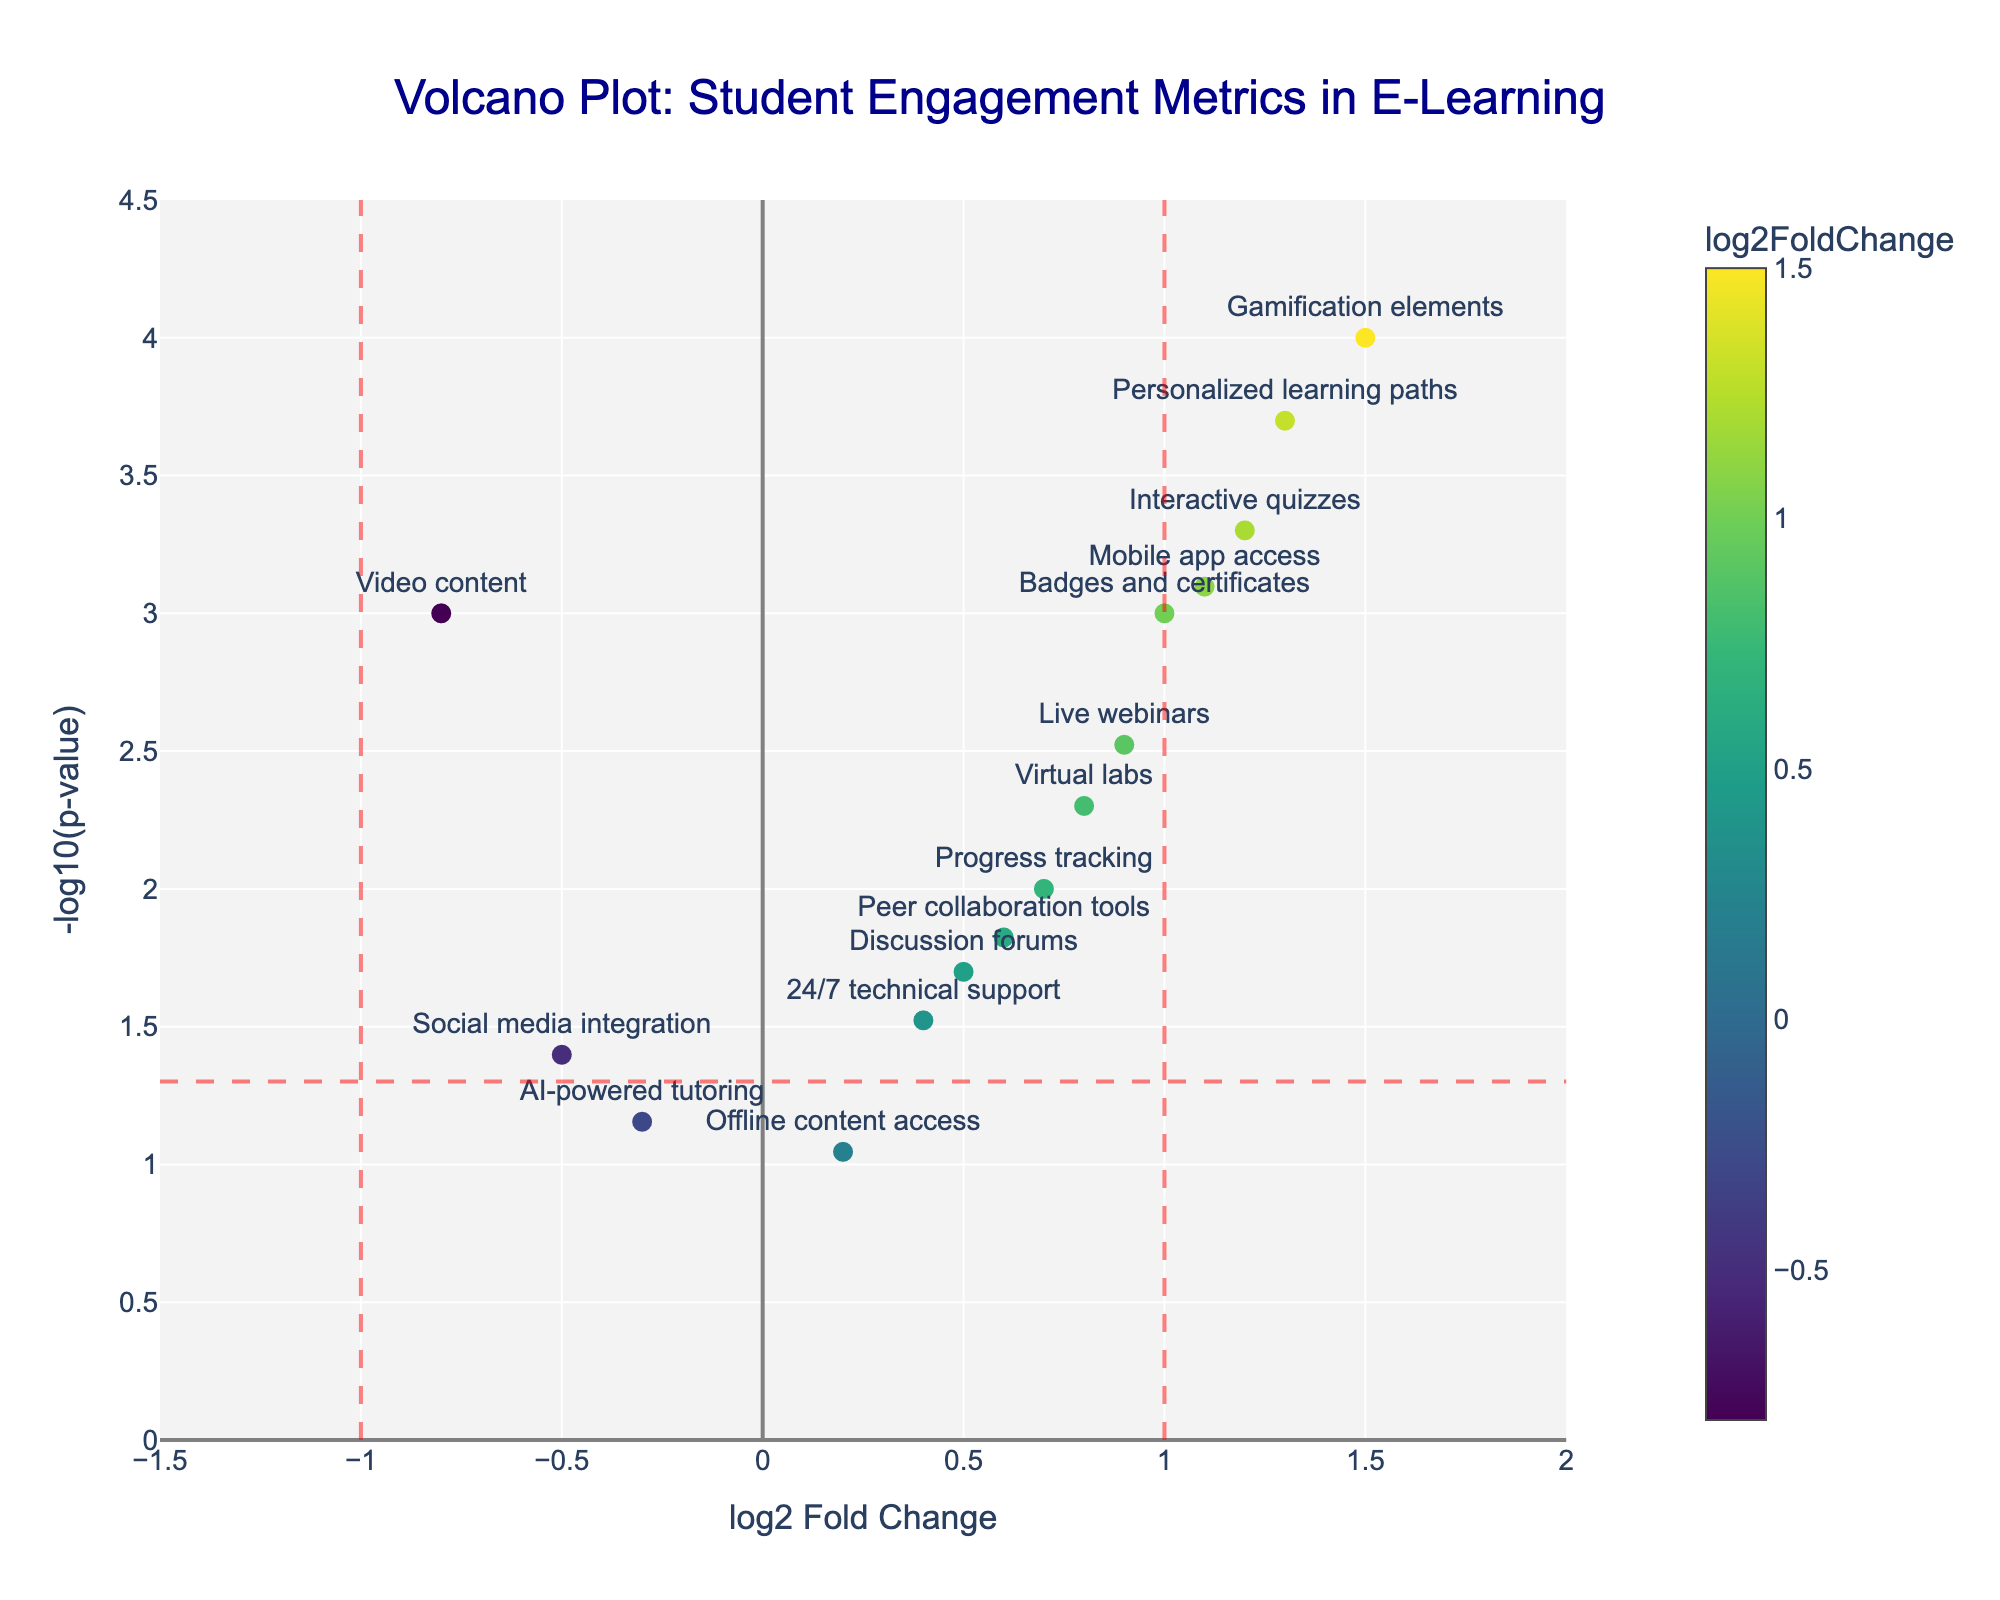What's the title of the plot? The title is usually located at the top center of the plot. In this figure, the title is clearly shown at the top.
Answer: Volcano Plot: Student Engagement Metrics in E-Learning What are the x-axis and y-axis labels? The x-axis and y-axis labels are found on the horizontal and vertical axes, respectively. They describe the data's meaning along each axis.
Answer: log2 Fold Change (x-axis) and -log10(p-value) (y-axis) How many features are above the -log10(p-value) = 1.3 threshold indicating significance? Count the markers above the red horizontal dashed line that represents -log10(0.05)= 1.3.
Answer: 10 markers 